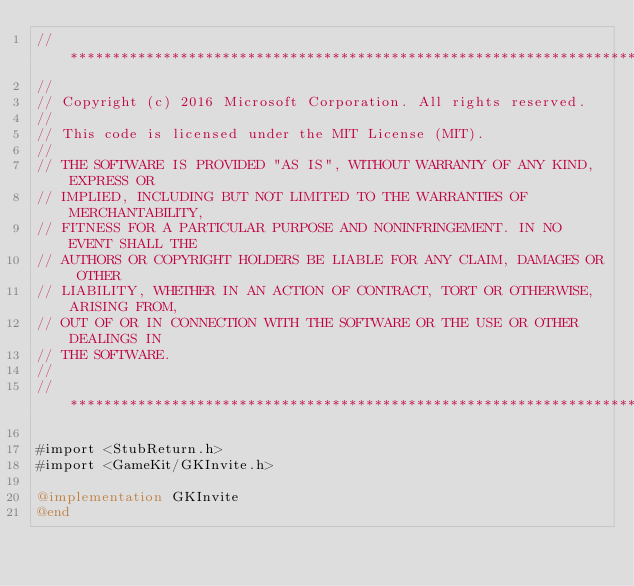<code> <loc_0><loc_0><loc_500><loc_500><_ObjectiveC_>//******************************************************************************
//
// Copyright (c) 2016 Microsoft Corporation. All rights reserved.
//
// This code is licensed under the MIT License (MIT).
//
// THE SOFTWARE IS PROVIDED "AS IS", WITHOUT WARRANTY OF ANY KIND, EXPRESS OR
// IMPLIED, INCLUDING BUT NOT LIMITED TO THE WARRANTIES OF MERCHANTABILITY,
// FITNESS FOR A PARTICULAR PURPOSE AND NONINFRINGEMENT. IN NO EVENT SHALL THE
// AUTHORS OR COPYRIGHT HOLDERS BE LIABLE FOR ANY CLAIM, DAMAGES OR OTHER
// LIABILITY, WHETHER IN AN ACTION OF CONTRACT, TORT OR OTHERWISE, ARISING FROM,
// OUT OF OR IN CONNECTION WITH THE SOFTWARE OR THE USE OR OTHER DEALINGS IN
// THE SOFTWARE.
//
//******************************************************************************

#import <StubReturn.h>
#import <GameKit/GKInvite.h>

@implementation GKInvite
@end
</code> 